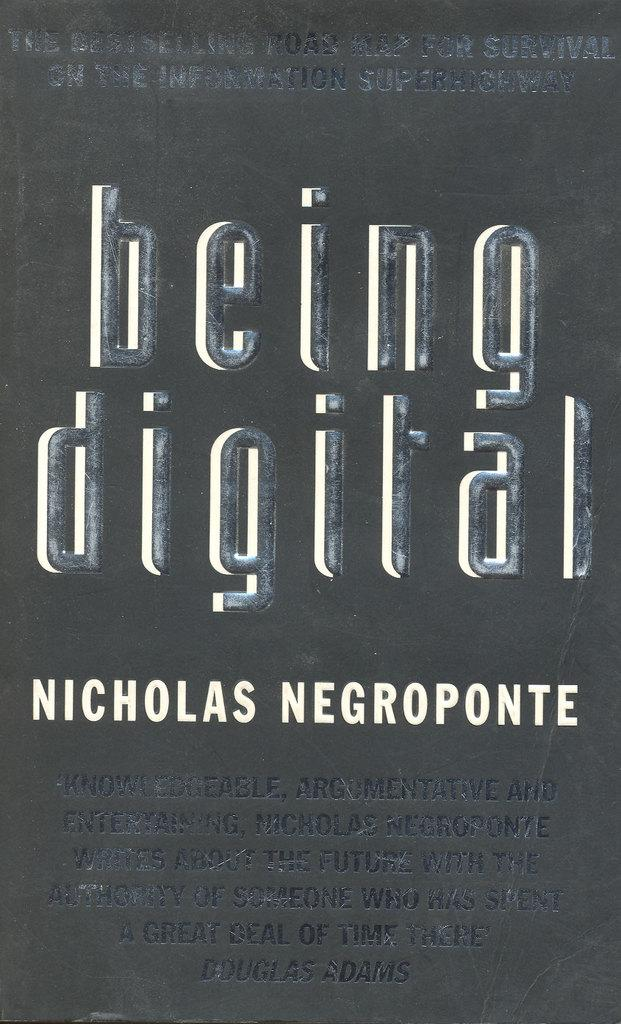<image>
Create a compact narrative representing the image presented. a book that is titled 'being digital' by nicholas negroponte 